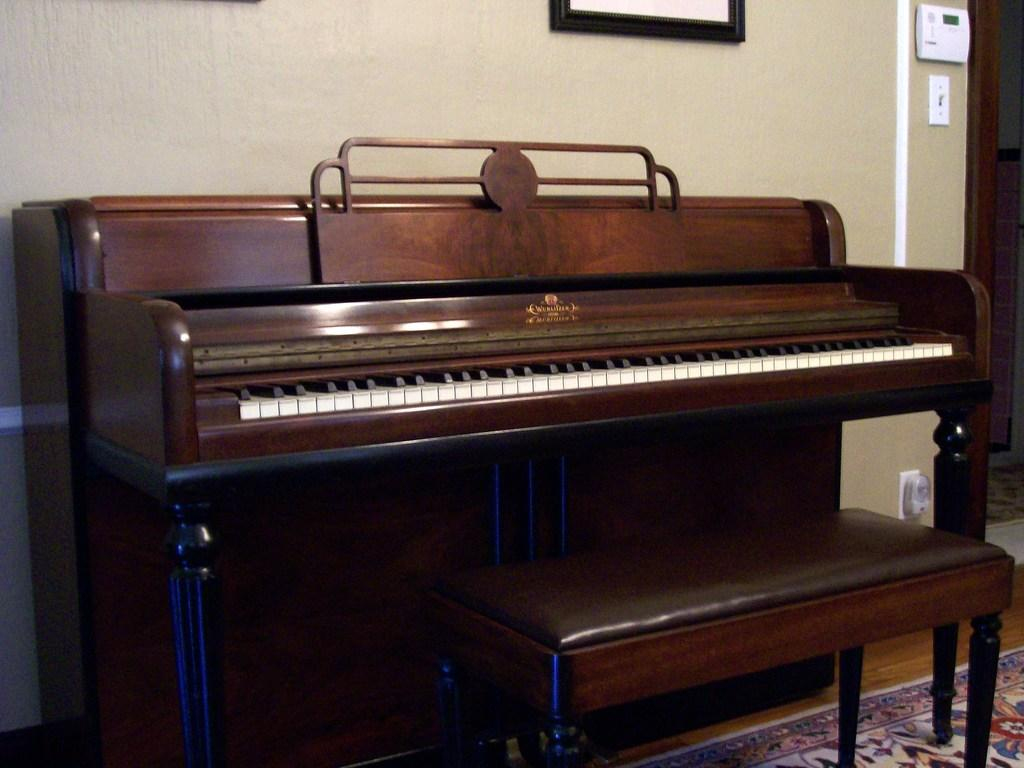Where was the image taken? The image was taken inside a room. What can be seen on one of the walls in the room? There is a wall painting in the room. How is the wall painting positioned in the room? The wall painting is attached to a wall. What musical instrument is present in the room? There is a piano in the room. What type of furniture is in the room? There is a chair in the room. What type of pie is being served in the lunchroom in the image? There is no lunchroom or pie present in the image; it is a room with a wall painting, a piano, and a chair. 